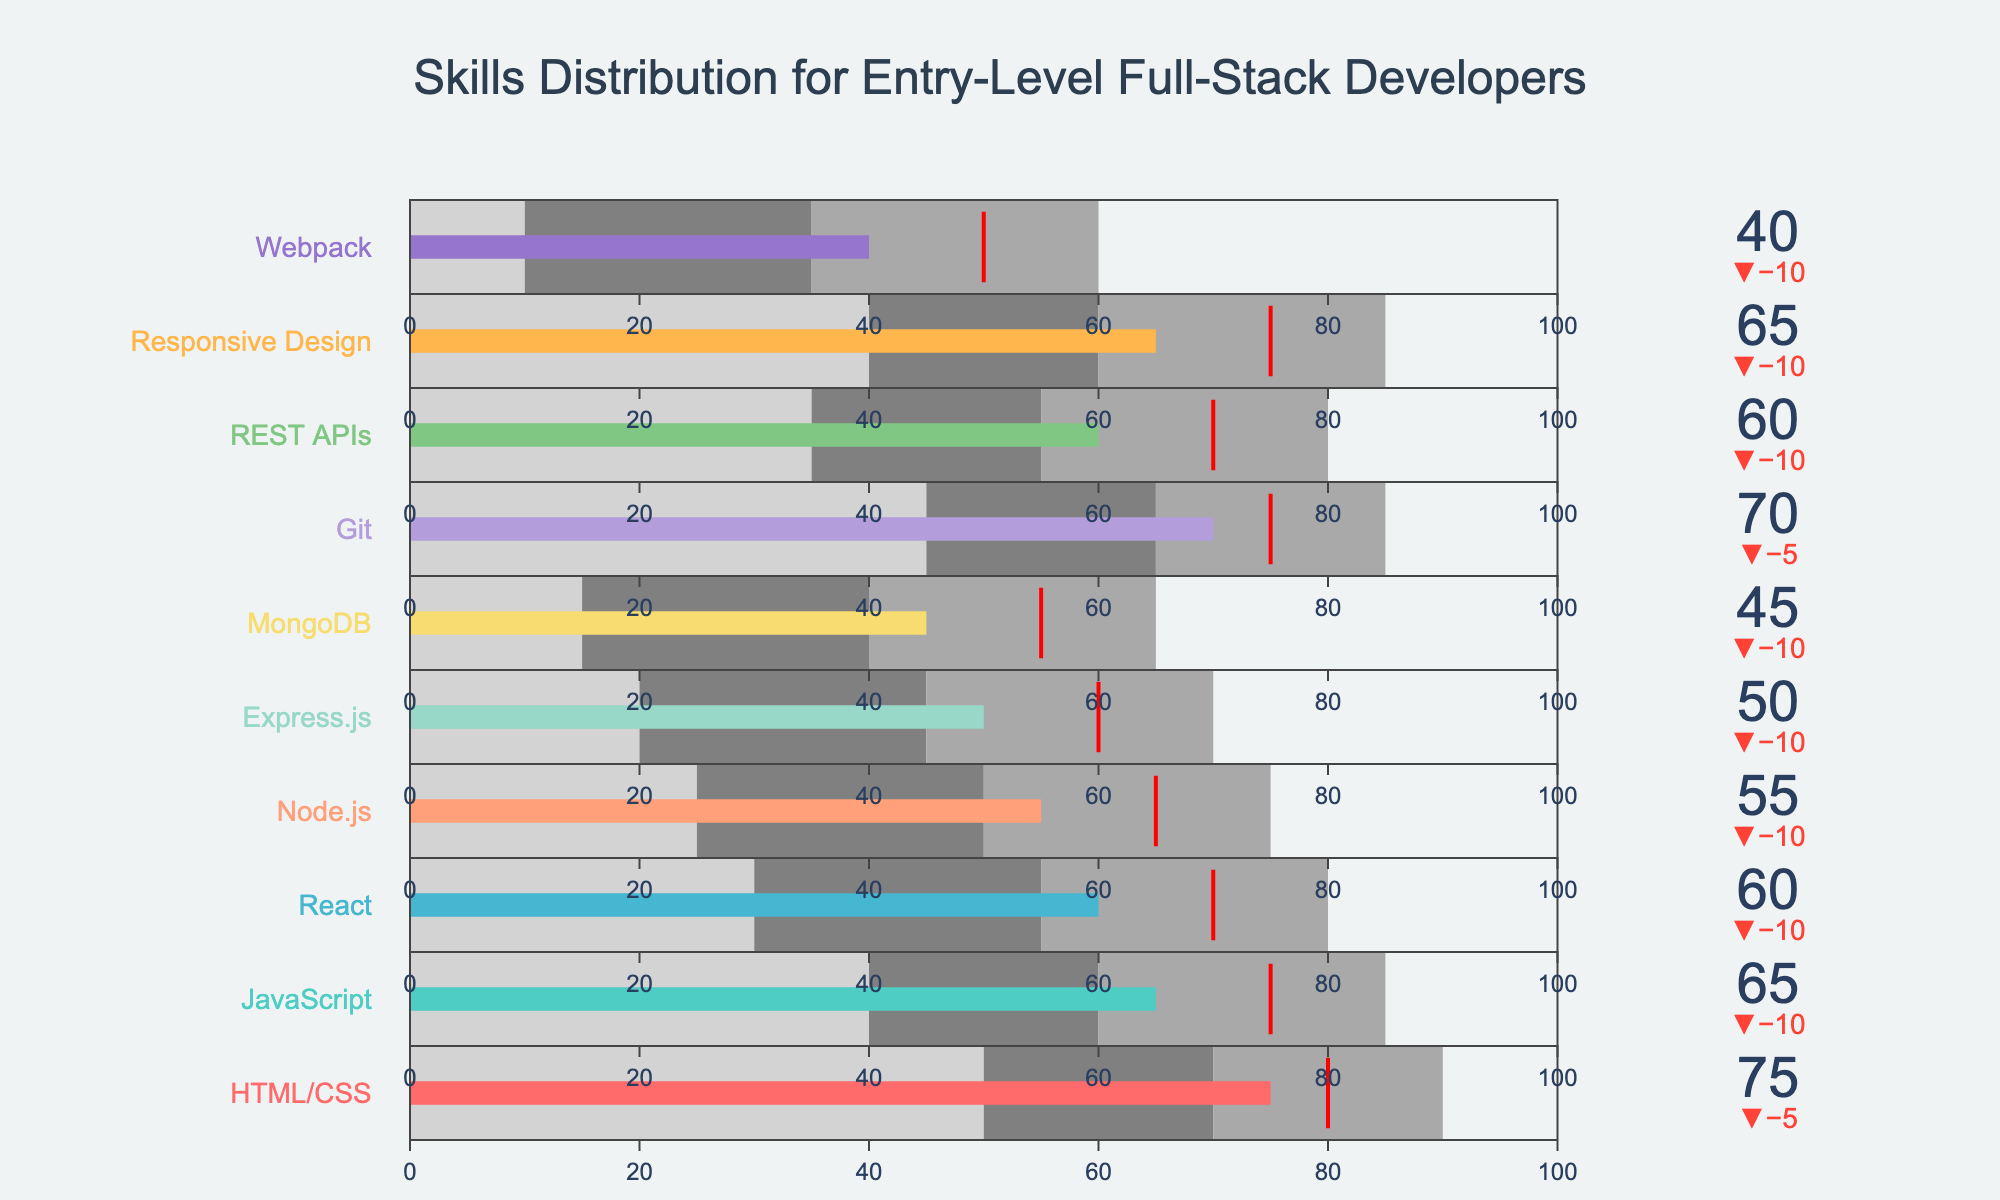What is the title of the figure? The title is located at the top of the figure and it provides a summary of what the plot represents. In this case, it reads "Skills Distribution for Entry-Level Full-Stack Developers."
Answer: Skills Distribution for Entry-Level Full-Stack Developers How many skills are displayed in the figure? Each bullet chart corresponds to a different skill and there is a separate trace for each skill. Count the number of bullet charts to find the total number of skills displayed. There are ten bullet charts in the figure.
Answer: 10 What is the actual value of MongoDB as shown in the bullet chart? The actual value for each skill is displayed by the length of the bar in the bullet chart. For MongoDB, the bar stops at the 45 mark.
Answer: 45 Which skill has the largest difference between the actual value and the target value? To find the skill with the largest difference, check the delta for each skill. The delta is the difference between the actual and target values. The skill with the highest mismatch (delta) is Express.js with a difference of -10.
Answer: Express.js Which skill's actual value is closest to its target value? To determine this, look for the skill where the actual value bar is closest to the red threshold marker. Git has an actual value closest to its target value, with both the actual value and target value being 75.
Answer: Git Which skills belong to the advanced category (above 60)? The advanced range starts from 60 onwards in each bullet chart. Identify the skills where the actual value surpasses this threshold. HTML/CSS, JavaScript, React, Git, and Responsive Design belong to the advanced category as their values are 75, 65, 60, 70, and 65 respectively.
Answer: HTML/CSS, JavaScript, React, Git, Responsive Design What is the combined actual value for HTML/CSS, JavaScript, and Node.js? Add the actual values for HTML/CSS (75), JavaScript (65), and Node.js (55). 75 + 65 + 55 = 195.
Answer: 195 In which skill is the beginner threshold highest? Look for the beginning threshold values in each bullet chart. HTML/CSS has the highest beginner threshold at 50.
Answer: HTML/CSS What's the average actual value of all the skills shown? To find the average actual value, sum up all the actual values and then divide by the number of skills. The actual values sum up to 585. Dividing by 10 (number of skills) gives 58.5.
Answer: 58.5 Which skill has its actual value in the "dark gray" intermediate range? The intermediate range is visually represented in dark gray in the bullet charts. Find where the actual value bar falls within this range. For React, the actual value is 60 which is within the intermediate range (55-80).
Answer: React 